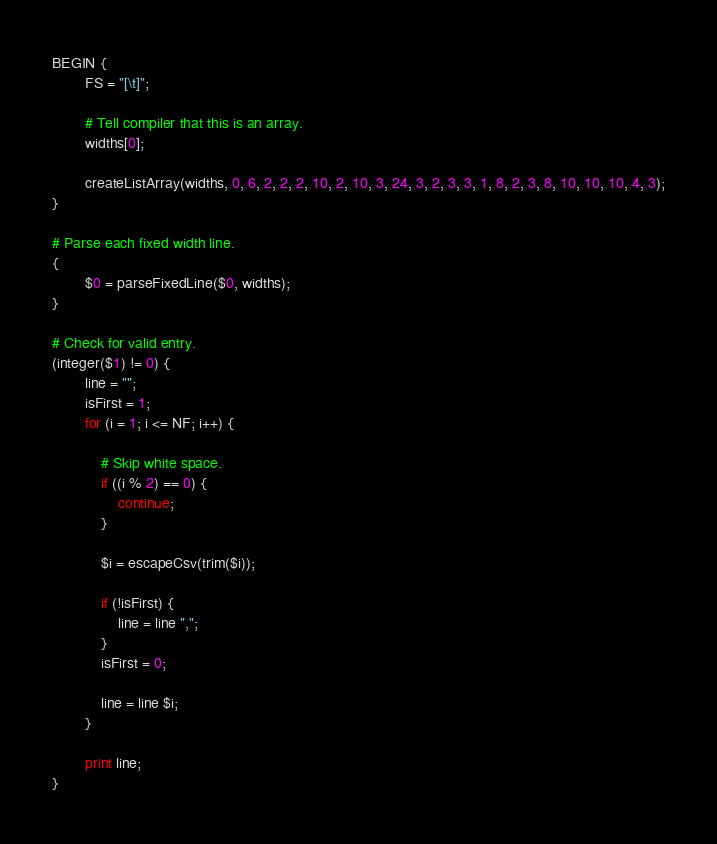Convert code to text. <code><loc_0><loc_0><loc_500><loc_500><_Awk_>BEGIN {
        FS = "[\t]";
        
        # Tell compiler that this is an array.
        widths[0];
        
        createListArray(widths, 0, 6, 2, 2, 2, 10, 2, 10, 3, 24, 3, 2, 3, 3, 1, 8, 2, 3, 8, 10, 10, 10, 4, 3);
}

# Parse each fixed width line.
{
        $0 = parseFixedLine($0, widths);
}

# Check for valid entry.
(integer($1) != 0) {
        line = "";
        isFirst = 1;
        for (i = 1; i <= NF; i++) {
        
            # Skip white space.
            if ((i % 2) == 0) {
                continue;
            }
        
            $i = escapeCsv(trim($i));
        
            if (!isFirst) {
                line = line ",";
            }
            isFirst = 0;
        
            line = line $i;
        }
    
        print line;
}
</code> 